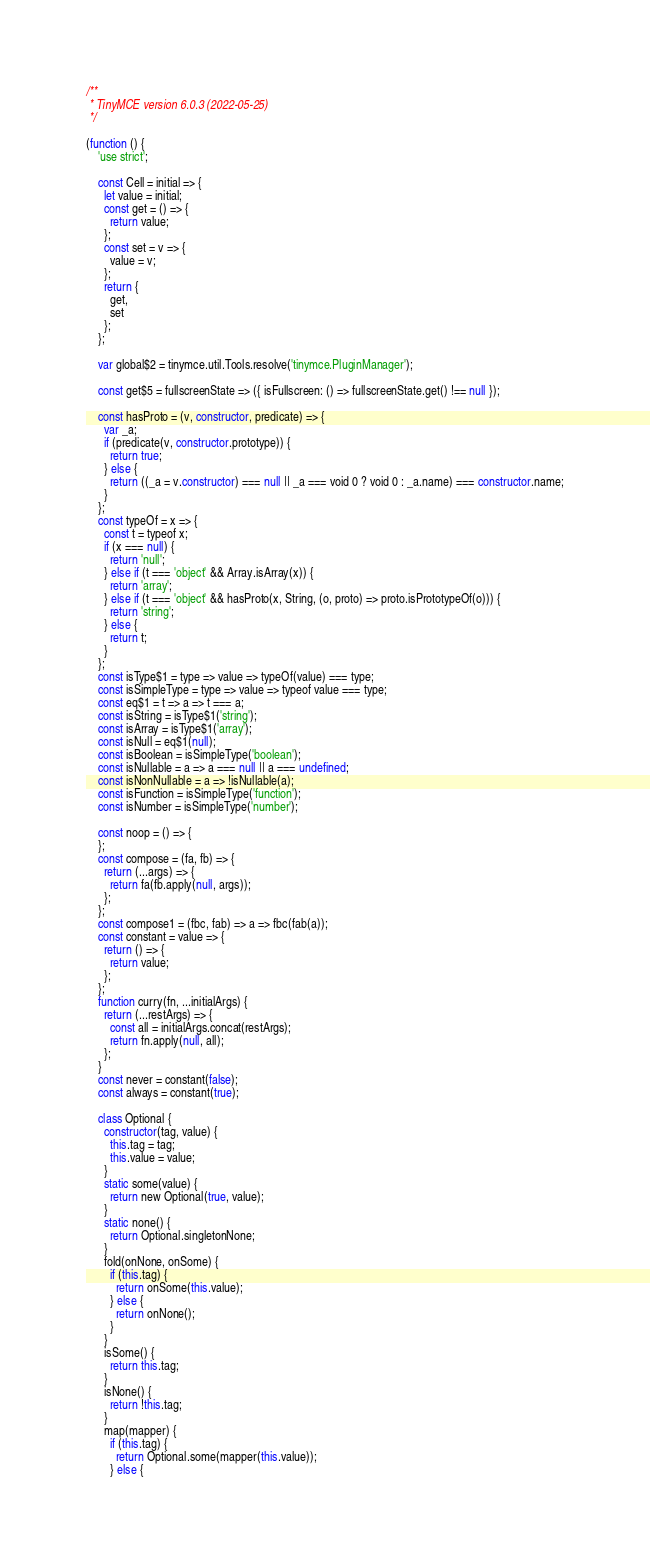Convert code to text. <code><loc_0><loc_0><loc_500><loc_500><_JavaScript_>/**
 * TinyMCE version 6.0.3 (2022-05-25)
 */

(function () {
    'use strict';

    const Cell = initial => {
      let value = initial;
      const get = () => {
        return value;
      };
      const set = v => {
        value = v;
      };
      return {
        get,
        set
      };
    };

    var global$2 = tinymce.util.Tools.resolve('tinymce.PluginManager');

    const get$5 = fullscreenState => ({ isFullscreen: () => fullscreenState.get() !== null });

    const hasProto = (v, constructor, predicate) => {
      var _a;
      if (predicate(v, constructor.prototype)) {
        return true;
      } else {
        return ((_a = v.constructor) === null || _a === void 0 ? void 0 : _a.name) === constructor.name;
      }
    };
    const typeOf = x => {
      const t = typeof x;
      if (x === null) {
        return 'null';
      } else if (t === 'object' && Array.isArray(x)) {
        return 'array';
      } else if (t === 'object' && hasProto(x, String, (o, proto) => proto.isPrototypeOf(o))) {
        return 'string';
      } else {
        return t;
      }
    };
    const isType$1 = type => value => typeOf(value) === type;
    const isSimpleType = type => value => typeof value === type;
    const eq$1 = t => a => t === a;
    const isString = isType$1('string');
    const isArray = isType$1('array');
    const isNull = eq$1(null);
    const isBoolean = isSimpleType('boolean');
    const isNullable = a => a === null || a === undefined;
    const isNonNullable = a => !isNullable(a);
    const isFunction = isSimpleType('function');
    const isNumber = isSimpleType('number');

    const noop = () => {
    };
    const compose = (fa, fb) => {
      return (...args) => {
        return fa(fb.apply(null, args));
      };
    };
    const compose1 = (fbc, fab) => a => fbc(fab(a));
    const constant = value => {
      return () => {
        return value;
      };
    };
    function curry(fn, ...initialArgs) {
      return (...restArgs) => {
        const all = initialArgs.concat(restArgs);
        return fn.apply(null, all);
      };
    }
    const never = constant(false);
    const always = constant(true);

    class Optional {
      constructor(tag, value) {
        this.tag = tag;
        this.value = value;
      }
      static some(value) {
        return new Optional(true, value);
      }
      static none() {
        return Optional.singletonNone;
      }
      fold(onNone, onSome) {
        if (this.tag) {
          return onSome(this.value);
        } else {
          return onNone();
        }
      }
      isSome() {
        return this.tag;
      }
      isNone() {
        return !this.tag;
      }
      map(mapper) {
        if (this.tag) {
          return Optional.some(mapper(this.value));
        } else {</code> 